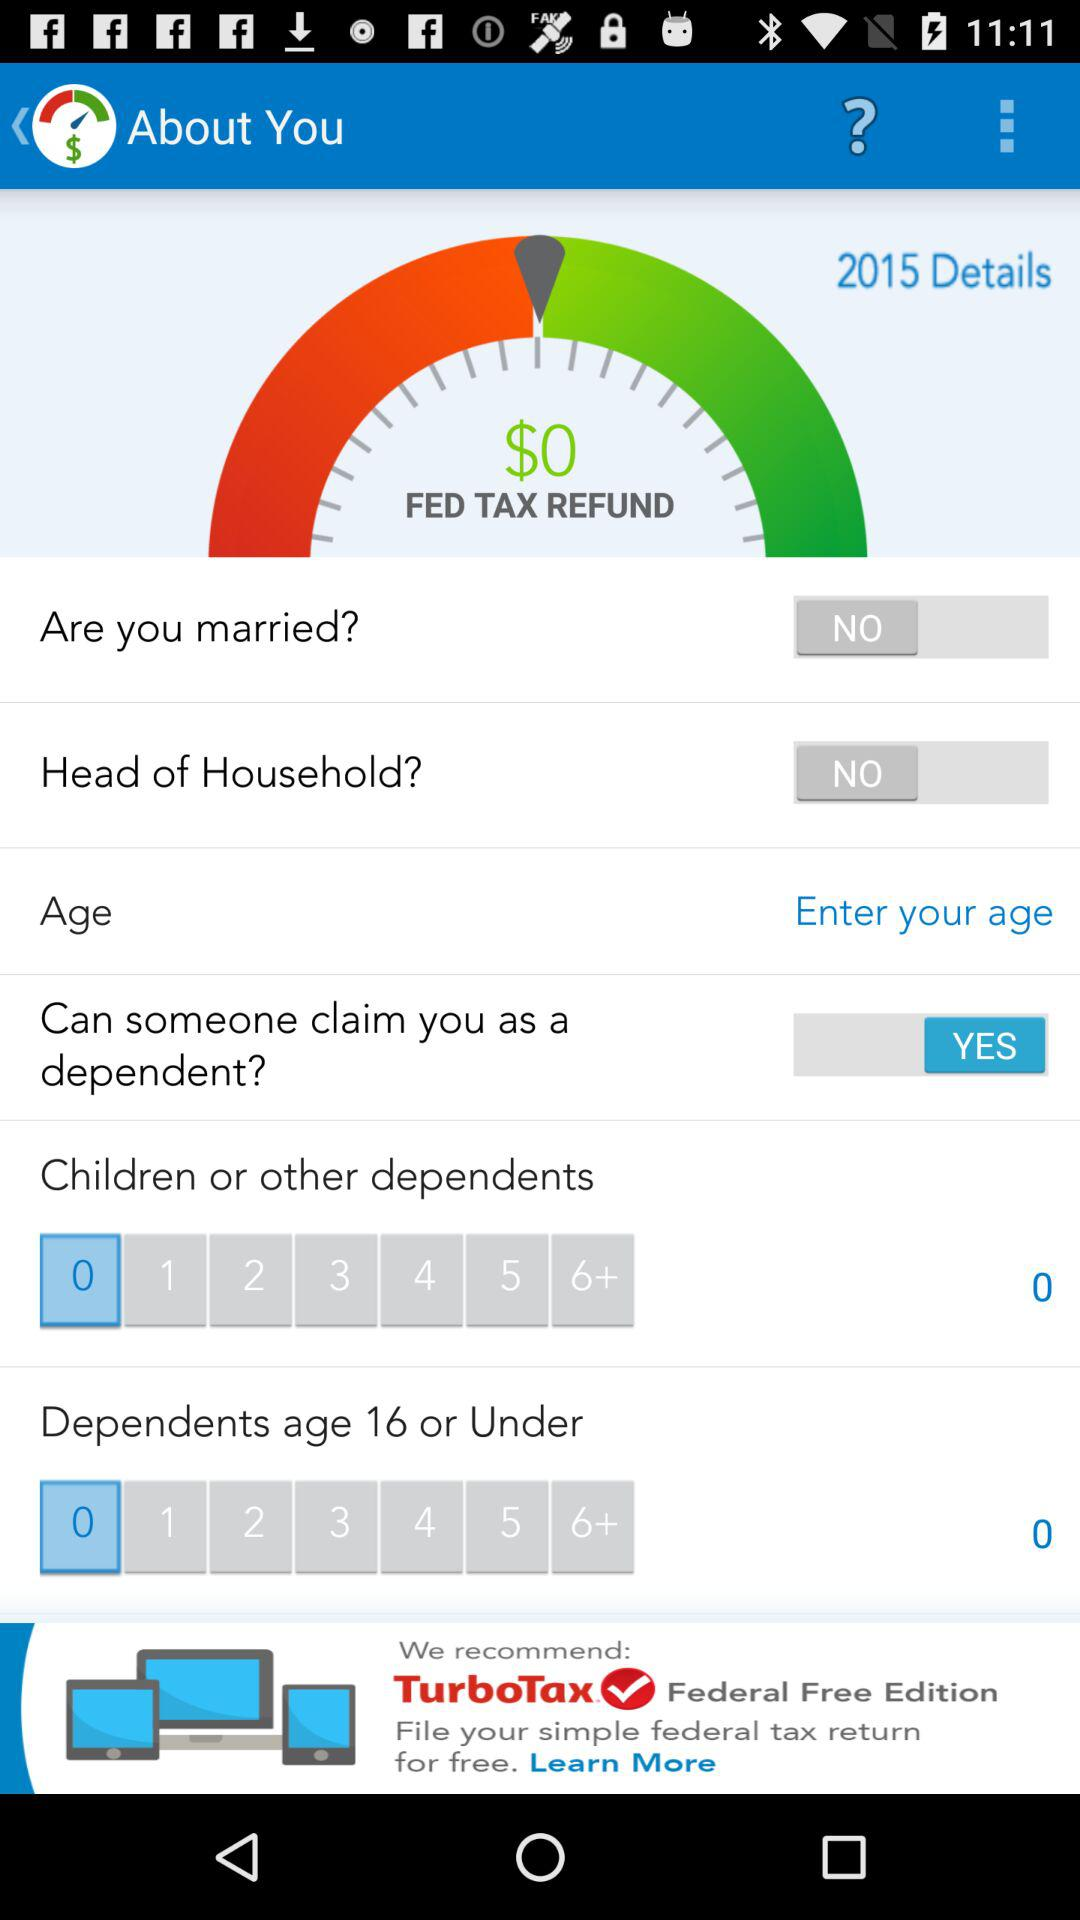What is the status of the "Head of Household?"? The status of the "Head of Household?" is "NO". 